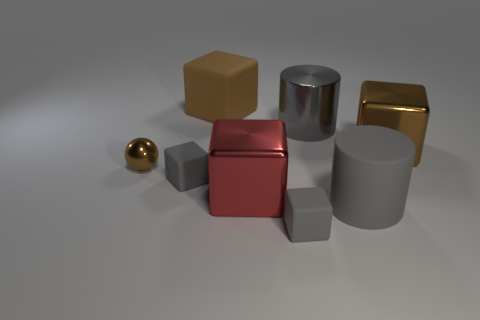Add 1 shiny cubes. How many objects exist? 9 Subtract all blocks. How many objects are left? 3 Add 6 big brown metallic objects. How many big brown metallic objects exist? 7 Subtract 0 green blocks. How many objects are left? 8 Subtract all large brown matte balls. Subtract all red metallic cubes. How many objects are left? 7 Add 2 large brown things. How many large brown things are left? 4 